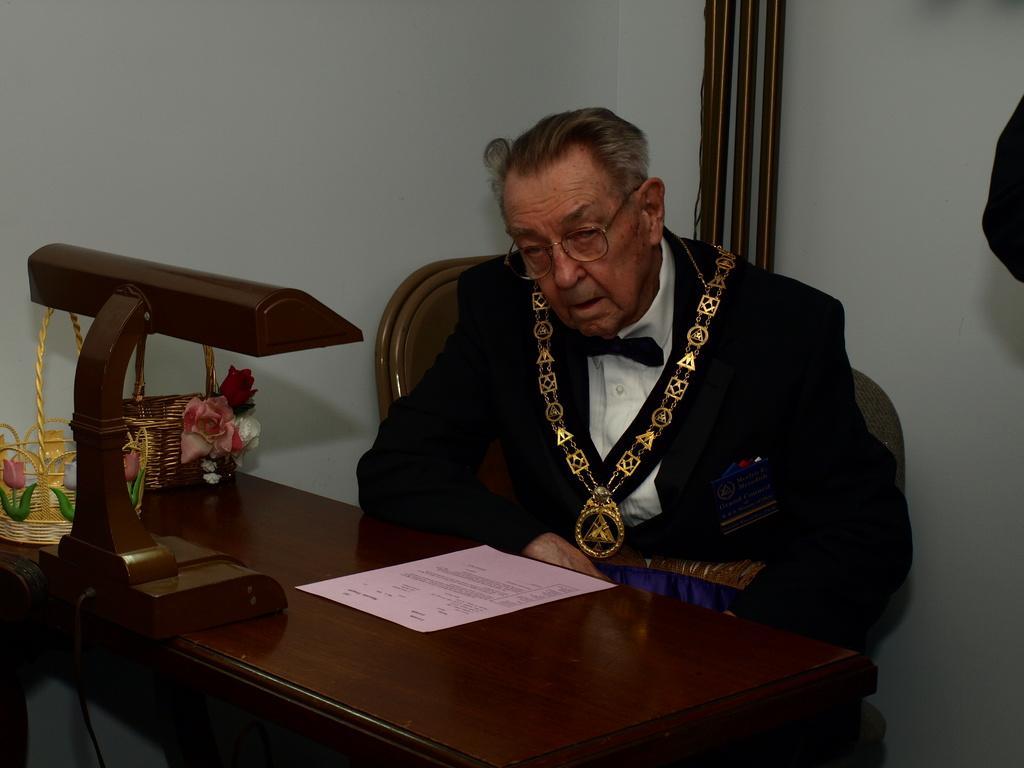How would you summarize this image in a sentence or two? This man is sitting on a chair. In-front of this man there is a table, on this table there are baskets, paper and wooden stand. 